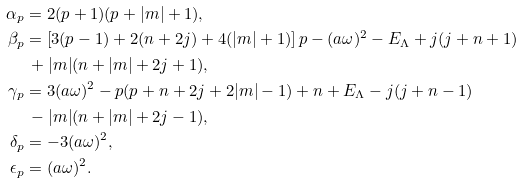<formula> <loc_0><loc_0><loc_500><loc_500>\alpha _ { p } & = 2 ( p + 1 ) ( p + | m | + 1 ) , \\ \beta _ { p } & = \left [ 3 ( p - 1 ) + 2 ( n + 2 j ) + 4 ( | m | + 1 ) \right ] p - ( a \omega ) ^ { 2 } - E _ { \Lambda } + j ( j + n + 1 ) \\ & \, + | m | ( n + | m | + 2 j + 1 ) , \\ \gamma _ { p } & = 3 ( a \omega ) ^ { 2 } - p ( p + n + 2 j + 2 | m | - 1 ) + n + E _ { \Lambda } - j ( j + n - 1 ) \\ & \, - | m | ( n + | m | + 2 j - 1 ) , \\ \delta _ { p } & = - 3 ( a \omega ) ^ { 2 } , \\ \epsilon _ { p } & = ( a \omega ) ^ { 2 } .</formula> 